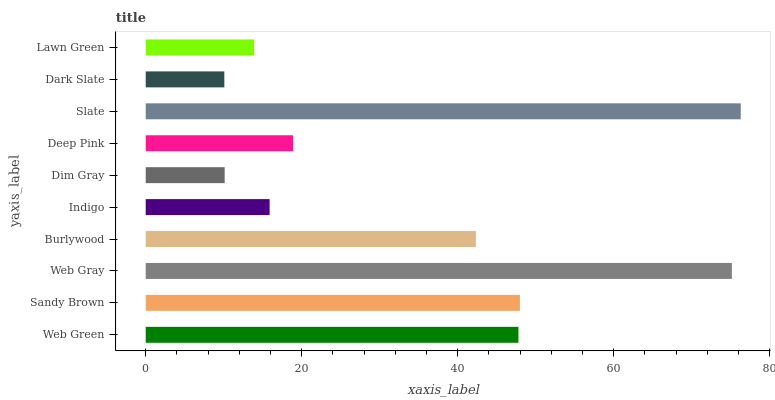Is Dark Slate the minimum?
Answer yes or no. Yes. Is Slate the maximum?
Answer yes or no. Yes. Is Sandy Brown the minimum?
Answer yes or no. No. Is Sandy Brown the maximum?
Answer yes or no. No. Is Sandy Brown greater than Web Green?
Answer yes or no. Yes. Is Web Green less than Sandy Brown?
Answer yes or no. Yes. Is Web Green greater than Sandy Brown?
Answer yes or no. No. Is Sandy Brown less than Web Green?
Answer yes or no. No. Is Burlywood the high median?
Answer yes or no. Yes. Is Deep Pink the low median?
Answer yes or no. Yes. Is Deep Pink the high median?
Answer yes or no. No. Is Dark Slate the low median?
Answer yes or no. No. 